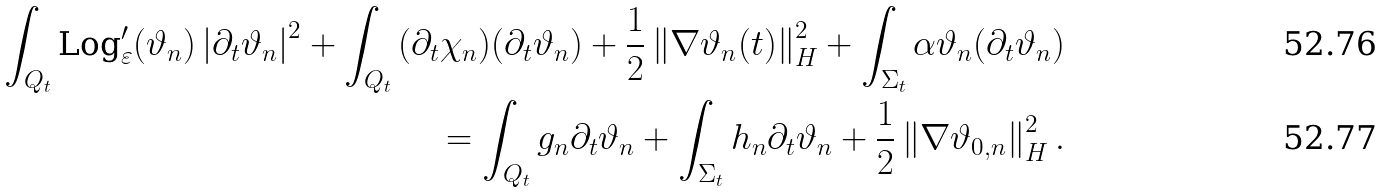Convert formula to latex. <formula><loc_0><loc_0><loc_500><loc_500>\int _ { Q _ { t } } { \text {Log} ^ { \prime } _ { \varepsilon } ( \vartheta _ { n } ) \left | \partial _ { t } \vartheta _ { n } \right | ^ { 2 } } + \int _ { Q _ { t } } { ( \partial _ { t } \chi _ { n } ) ( \partial _ { t } \vartheta _ { n } ) } + \frac { 1 } { 2 } \left \| \nabla \vartheta _ { n } ( t ) \right \| ^ { 2 } _ { H } + \int _ { \Sigma _ { t } } { \alpha \vartheta _ { n } ( \partial _ { t } \vartheta _ { n } ) } \\ = \int _ { Q _ { t } } { g _ { n } \partial _ { t } \vartheta _ { n } } + \int _ { \Sigma _ { t } } { h _ { n } \partial _ { t } \vartheta _ { n } } + \frac { 1 } { 2 } \left \| \nabla \vartheta _ { 0 , n } \right \| ^ { 2 } _ { H } .</formula> 